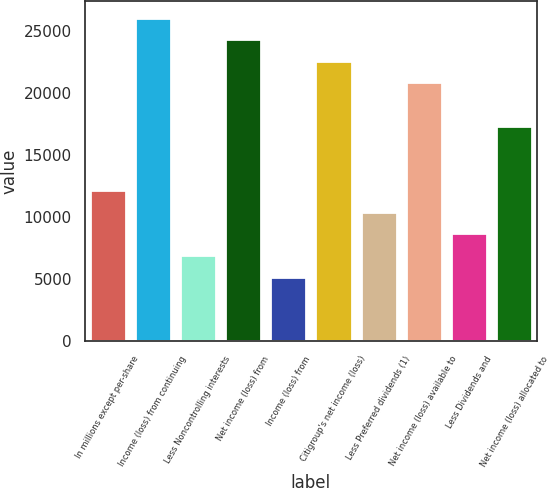Convert chart to OTSL. <chart><loc_0><loc_0><loc_500><loc_500><bar_chart><fcel>In millions except per-share<fcel>Income (loss) from continuing<fcel>Less Noncontrolling interests<fcel>Net income (loss) from<fcel>Income (loss) from<fcel>Citigroup's net income (loss)<fcel>Less Preferred dividends (1)<fcel>Net income (loss) available to<fcel>Less Dividends and<fcel>Net income (loss) allocated to<nl><fcel>12170.2<fcel>26079<fcel>6954.42<fcel>24340.4<fcel>5215.82<fcel>22601.8<fcel>10431.6<fcel>20863.2<fcel>8693.02<fcel>17386<nl></chart> 